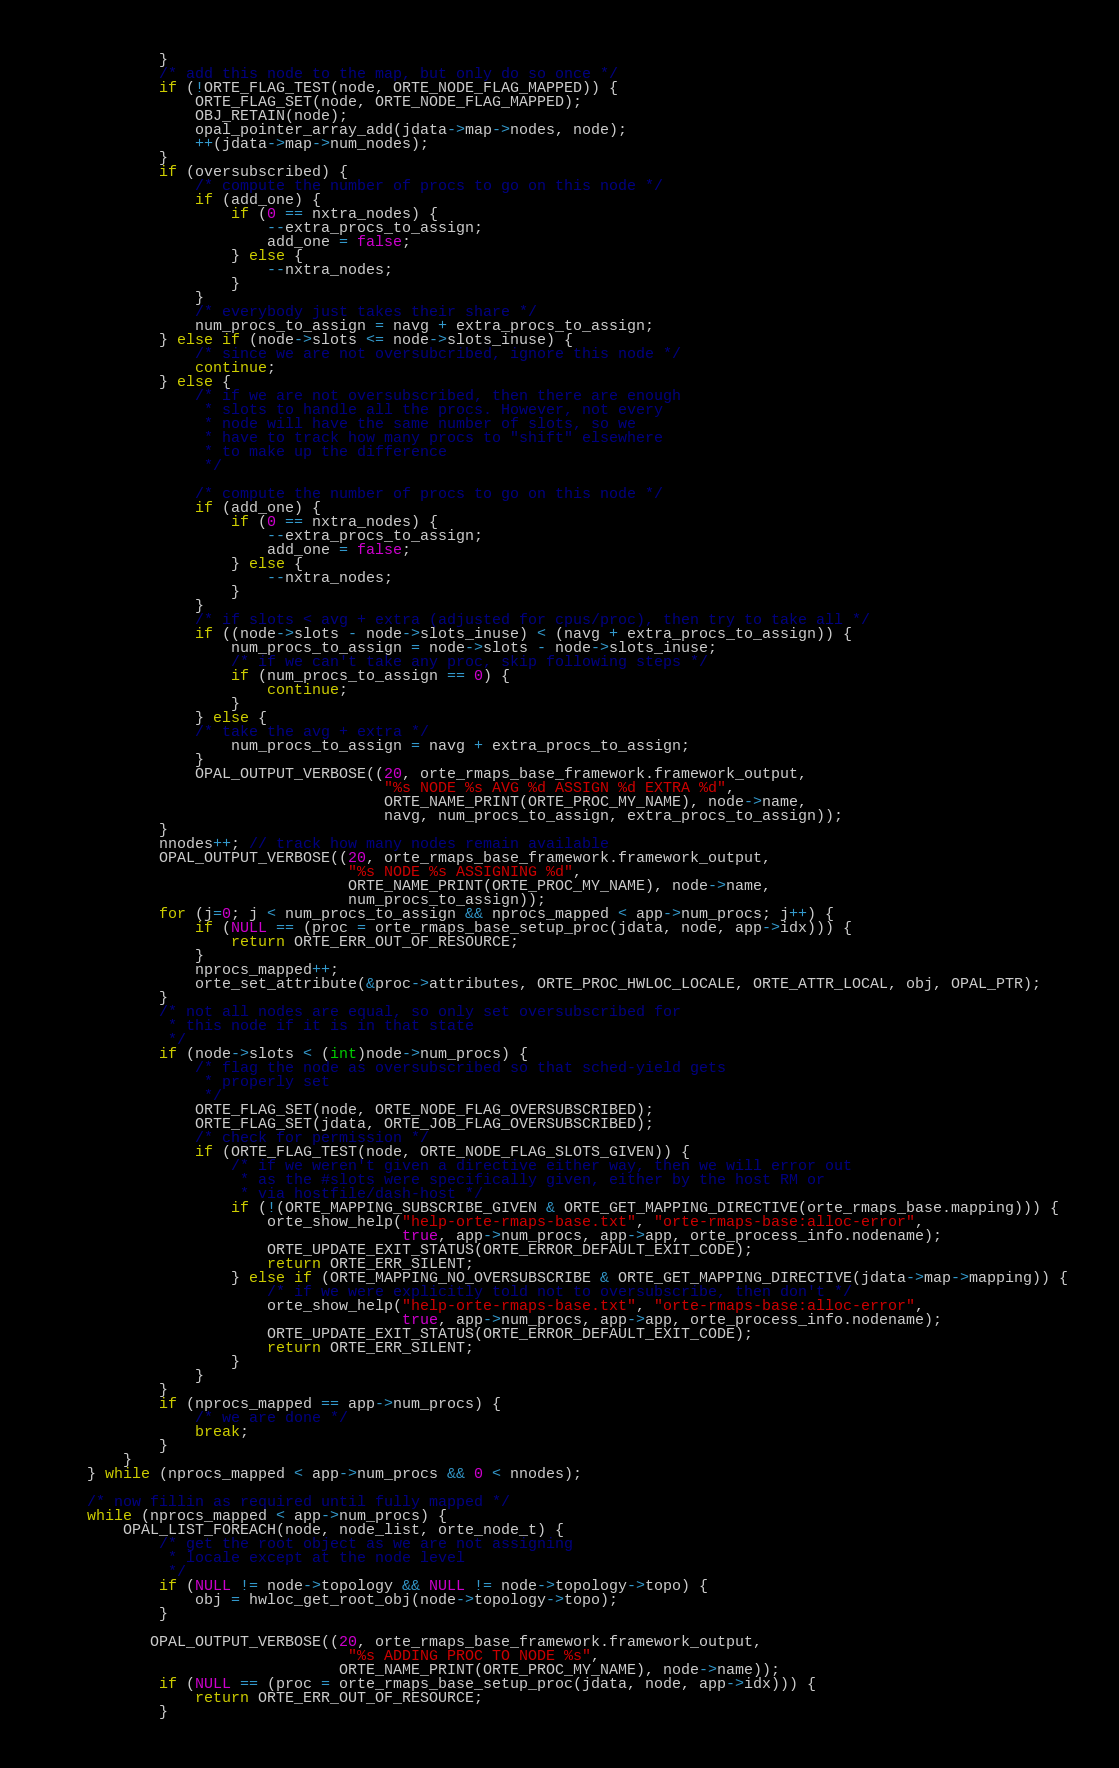<code> <loc_0><loc_0><loc_500><loc_500><_C_>            }
            /* add this node to the map, but only do so once */
            if (!ORTE_FLAG_TEST(node, ORTE_NODE_FLAG_MAPPED)) {
                ORTE_FLAG_SET(node, ORTE_NODE_FLAG_MAPPED);
                OBJ_RETAIN(node);
                opal_pointer_array_add(jdata->map->nodes, node);
                ++(jdata->map->num_nodes);
            }
            if (oversubscribed) {
                /* compute the number of procs to go on this node */
                if (add_one) {
                    if (0 == nxtra_nodes) {
                        --extra_procs_to_assign;
                        add_one = false;
                    } else {
                        --nxtra_nodes;
                    }
                }
                /* everybody just takes their share */
                num_procs_to_assign = navg + extra_procs_to_assign;
            } else if (node->slots <= node->slots_inuse) {
                /* since we are not oversubcribed, ignore this node */
                continue;
            } else {
                /* if we are not oversubscribed, then there are enough
                 * slots to handle all the procs. However, not every
                 * node will have the same number of slots, so we
                 * have to track how many procs to "shift" elsewhere
                 * to make up the difference
                 */

                /* compute the number of procs to go on this node */
                if (add_one) {
                    if (0 == nxtra_nodes) {
                        --extra_procs_to_assign;
                        add_one = false;
                    } else {
                        --nxtra_nodes;
                    }
                }
                /* if slots < avg + extra (adjusted for cpus/proc), then try to take all */
                if ((node->slots - node->slots_inuse) < (navg + extra_procs_to_assign)) {
                    num_procs_to_assign = node->slots - node->slots_inuse;
                    /* if we can't take any proc, skip following steps */
                    if (num_procs_to_assign == 0) {
                        continue;
                    }
                } else {
                /* take the avg + extra */
                    num_procs_to_assign = navg + extra_procs_to_assign;
                }
                OPAL_OUTPUT_VERBOSE((20, orte_rmaps_base_framework.framework_output,
                                     "%s NODE %s AVG %d ASSIGN %d EXTRA %d",
                                     ORTE_NAME_PRINT(ORTE_PROC_MY_NAME), node->name,
                                     navg, num_procs_to_assign, extra_procs_to_assign));
            }
            nnodes++; // track how many nodes remain available
            OPAL_OUTPUT_VERBOSE((20, orte_rmaps_base_framework.framework_output,
                                 "%s NODE %s ASSIGNING %d",
                                 ORTE_NAME_PRINT(ORTE_PROC_MY_NAME), node->name,
                                 num_procs_to_assign));
            for (j=0; j < num_procs_to_assign && nprocs_mapped < app->num_procs; j++) {
                if (NULL == (proc = orte_rmaps_base_setup_proc(jdata, node, app->idx))) {
                    return ORTE_ERR_OUT_OF_RESOURCE;
                }
                nprocs_mapped++;
                orte_set_attribute(&proc->attributes, ORTE_PROC_HWLOC_LOCALE, ORTE_ATTR_LOCAL, obj, OPAL_PTR);
            }
            /* not all nodes are equal, so only set oversubscribed for
             * this node if it is in that state
             */
            if (node->slots < (int)node->num_procs) {
                /* flag the node as oversubscribed so that sched-yield gets
                 * properly set
                 */
                ORTE_FLAG_SET(node, ORTE_NODE_FLAG_OVERSUBSCRIBED);
                ORTE_FLAG_SET(jdata, ORTE_JOB_FLAG_OVERSUBSCRIBED);
                /* check for permission */
                if (ORTE_FLAG_TEST(node, ORTE_NODE_FLAG_SLOTS_GIVEN)) {
                    /* if we weren't given a directive either way, then we will error out
                     * as the #slots were specifically given, either by the host RM or
                     * via hostfile/dash-host */
                    if (!(ORTE_MAPPING_SUBSCRIBE_GIVEN & ORTE_GET_MAPPING_DIRECTIVE(orte_rmaps_base.mapping))) {
                        orte_show_help("help-orte-rmaps-base.txt", "orte-rmaps-base:alloc-error",
                                       true, app->num_procs, app->app, orte_process_info.nodename);
                        ORTE_UPDATE_EXIT_STATUS(ORTE_ERROR_DEFAULT_EXIT_CODE);
                        return ORTE_ERR_SILENT;
                    } else if (ORTE_MAPPING_NO_OVERSUBSCRIBE & ORTE_GET_MAPPING_DIRECTIVE(jdata->map->mapping)) {
                        /* if we were explicitly told not to oversubscribe, then don't */
                        orte_show_help("help-orte-rmaps-base.txt", "orte-rmaps-base:alloc-error",
                                       true, app->num_procs, app->app, orte_process_info.nodename);
                        ORTE_UPDATE_EXIT_STATUS(ORTE_ERROR_DEFAULT_EXIT_CODE);
                        return ORTE_ERR_SILENT;
                    }
                }
            }
            if (nprocs_mapped == app->num_procs) {
                /* we are done */
                break;
            }
        }
    } while (nprocs_mapped < app->num_procs && 0 < nnodes);

    /* now fillin as required until fully mapped */
    while (nprocs_mapped < app->num_procs) {
        OPAL_LIST_FOREACH(node, node_list, orte_node_t) {
            /* get the root object as we are not assigning
             * locale except at the node level
             */
            if (NULL != node->topology && NULL != node->topology->topo) {
                obj = hwloc_get_root_obj(node->topology->topo);
            }

           OPAL_OUTPUT_VERBOSE((20, orte_rmaps_base_framework.framework_output,
                                 "%s ADDING PROC TO NODE %s",
                                ORTE_NAME_PRINT(ORTE_PROC_MY_NAME), node->name));
            if (NULL == (proc = orte_rmaps_base_setup_proc(jdata, node, app->idx))) {
                return ORTE_ERR_OUT_OF_RESOURCE;
            }</code> 